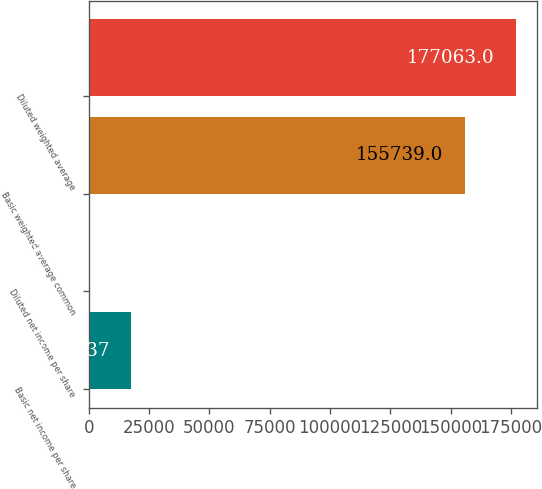<chart> <loc_0><loc_0><loc_500><loc_500><bar_chart><fcel>Basic net income per share<fcel>Diluted net income per share<fcel>Basic weighted average common<fcel>Diluted weighted average<nl><fcel>17706.4<fcel>0.08<fcel>155739<fcel>177063<nl></chart> 